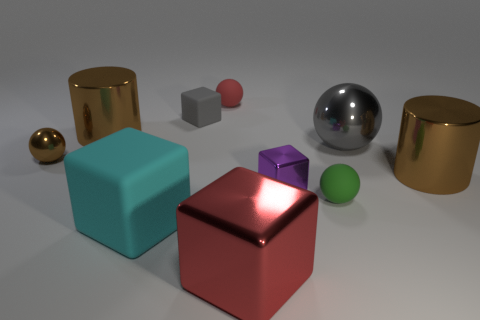Subtract all cylinders. How many objects are left? 8 Add 4 small balls. How many small balls exist? 7 Subtract 0 cyan balls. How many objects are left? 10 Subtract all purple blocks. Subtract all purple cubes. How many objects are left? 8 Add 4 small green rubber objects. How many small green rubber objects are left? 5 